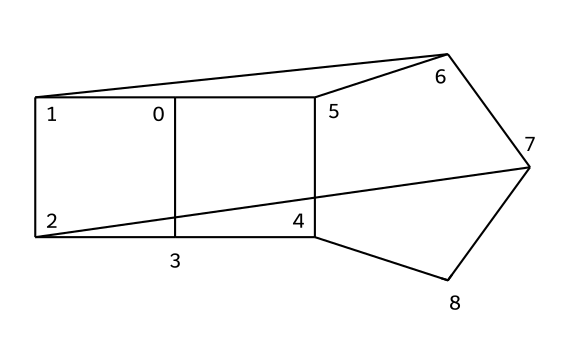How many carbon atoms are in adamantane? In the provided SMILES representation, counting the 'C' symbols gives a total of ten carbon atoms present in the structure of adamantane.
Answer: ten What is the molecular formula of adamantane? The structure can be analyzed, revealing that with ten carbon and sixteen hydrogen atoms present, the molecular formula can be deduced as C10H16.
Answer: C10H16 How many rings are present in the structure of adamantane? Viewing the structure, one can observe that adamantane has a cage-like formation consisting of three interconnected rings.
Answer: three Is adamantane a saturated or unsaturated hydrocarbon? Since all carbons in adamantane are connected by single bonds and there are no double or triple bonds, it is classified as a saturated hydrocarbon.
Answer: saturated What type of hydrocarbon is adamantane categorized as? Given the three-dimensional cage-like structure of adamantane, it specifically falls under the category of cage hydrocarbons.
Answer: cage hydrocarbon Which property of adamantane makes it suitable for use in lubricants? The robust, stable structure and low volatility of adamantane contribute to its lubricating properties, making it effective in hard drive lubricants.
Answer: stability 